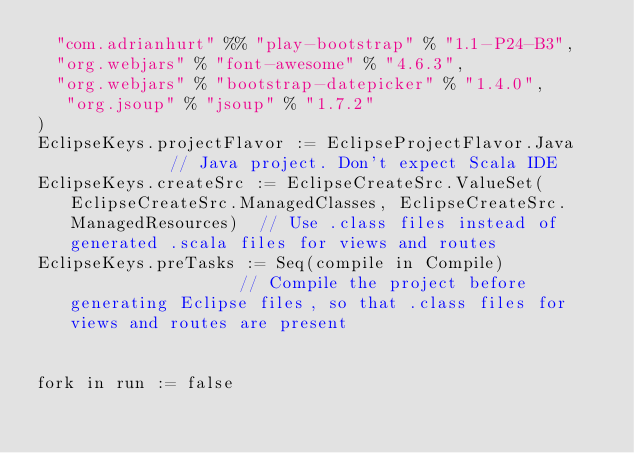<code> <loc_0><loc_0><loc_500><loc_500><_Scala_>  "com.adrianhurt" %% "play-bootstrap" % "1.1-P24-B3",
  "org.webjars" % "font-awesome" % "4.6.3",
  "org.webjars" % "bootstrap-datepicker" % "1.4.0",
   "org.jsoup" % "jsoup" % "1.7.2"
)
EclipseKeys.projectFlavor := EclipseProjectFlavor.Java           // Java project. Don't expect Scala IDE
EclipseKeys.createSrc := EclipseCreateSrc.ValueSet(EclipseCreateSrc.ManagedClasses, EclipseCreateSrc.ManagedResources)  // Use .class files instead of generated .scala files for views and routes 
EclipseKeys.preTasks := Seq(compile in Compile)                  // Compile the project before generating Eclipse files, so that .class files for views and routes are present                


fork in run := false</code> 